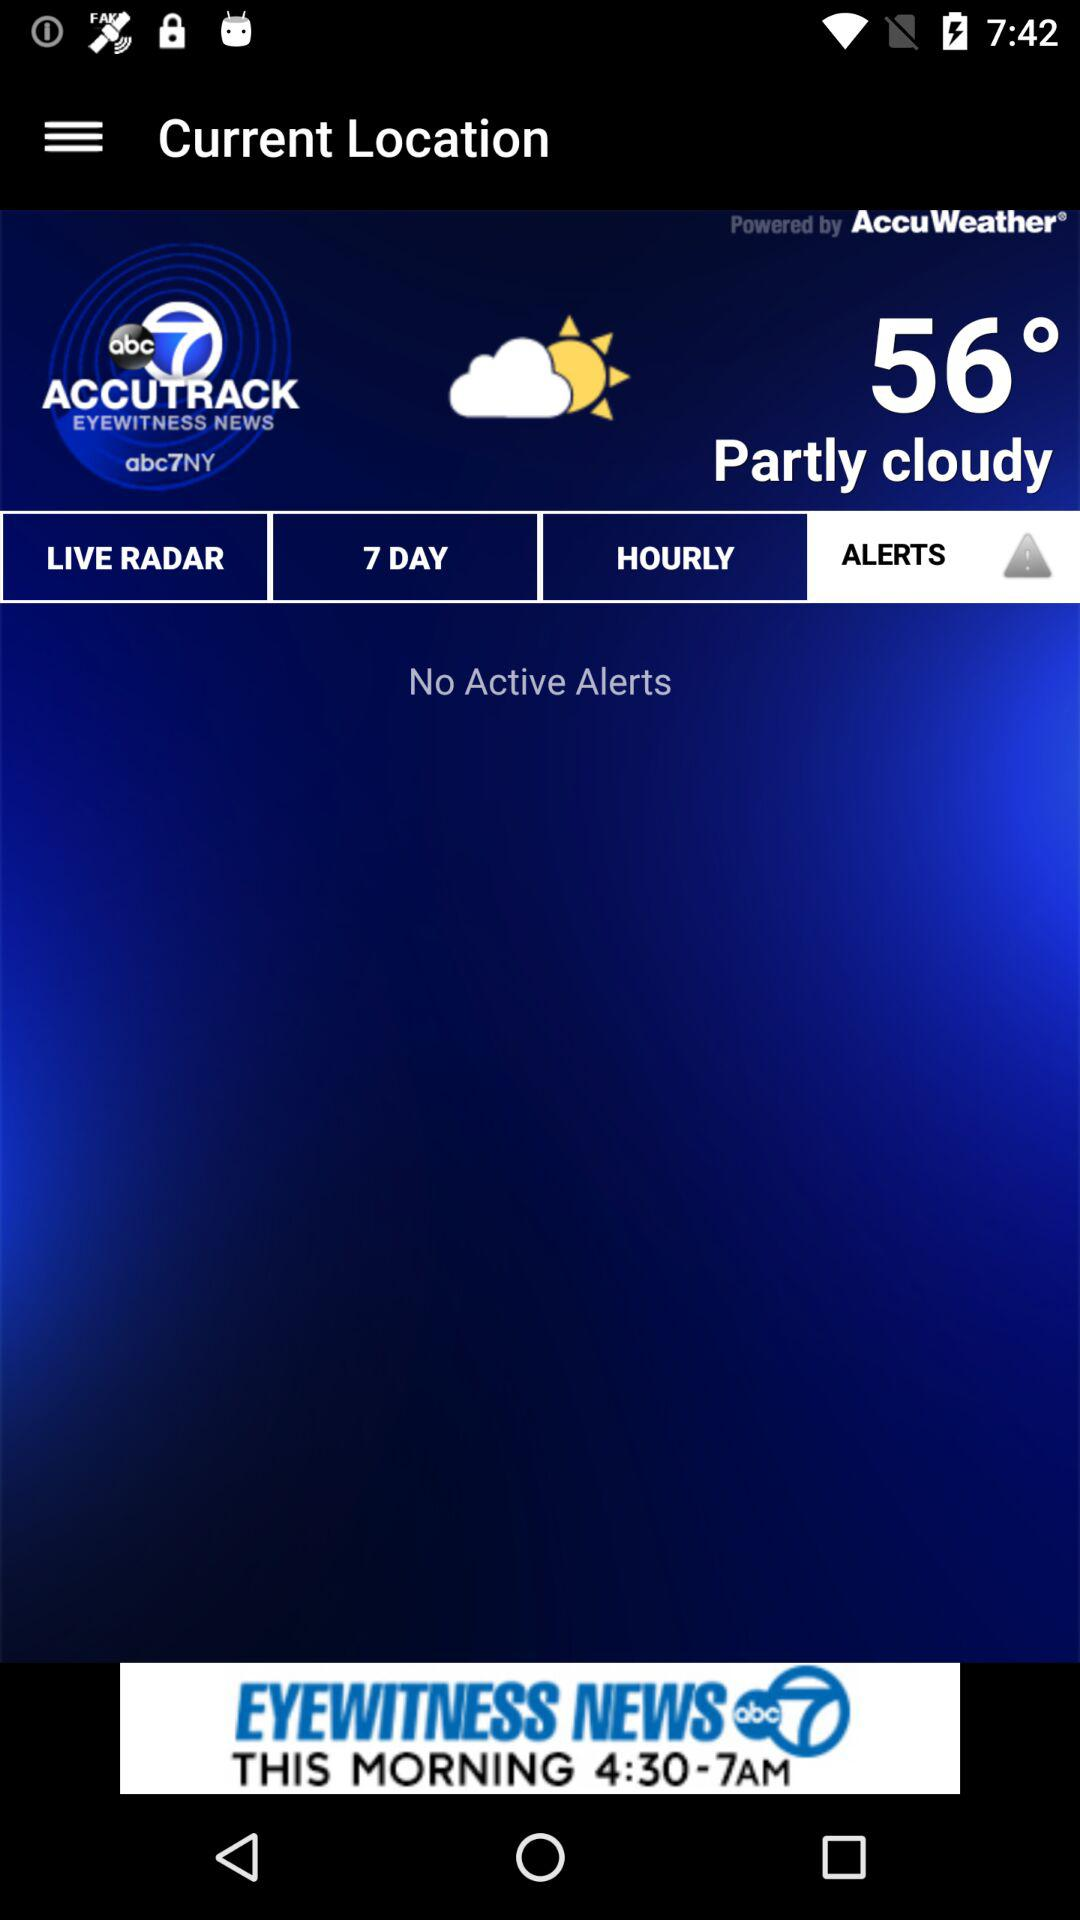How many degrees warmer is it than 50 degrees?
Answer the question using a single word or phrase. 6 